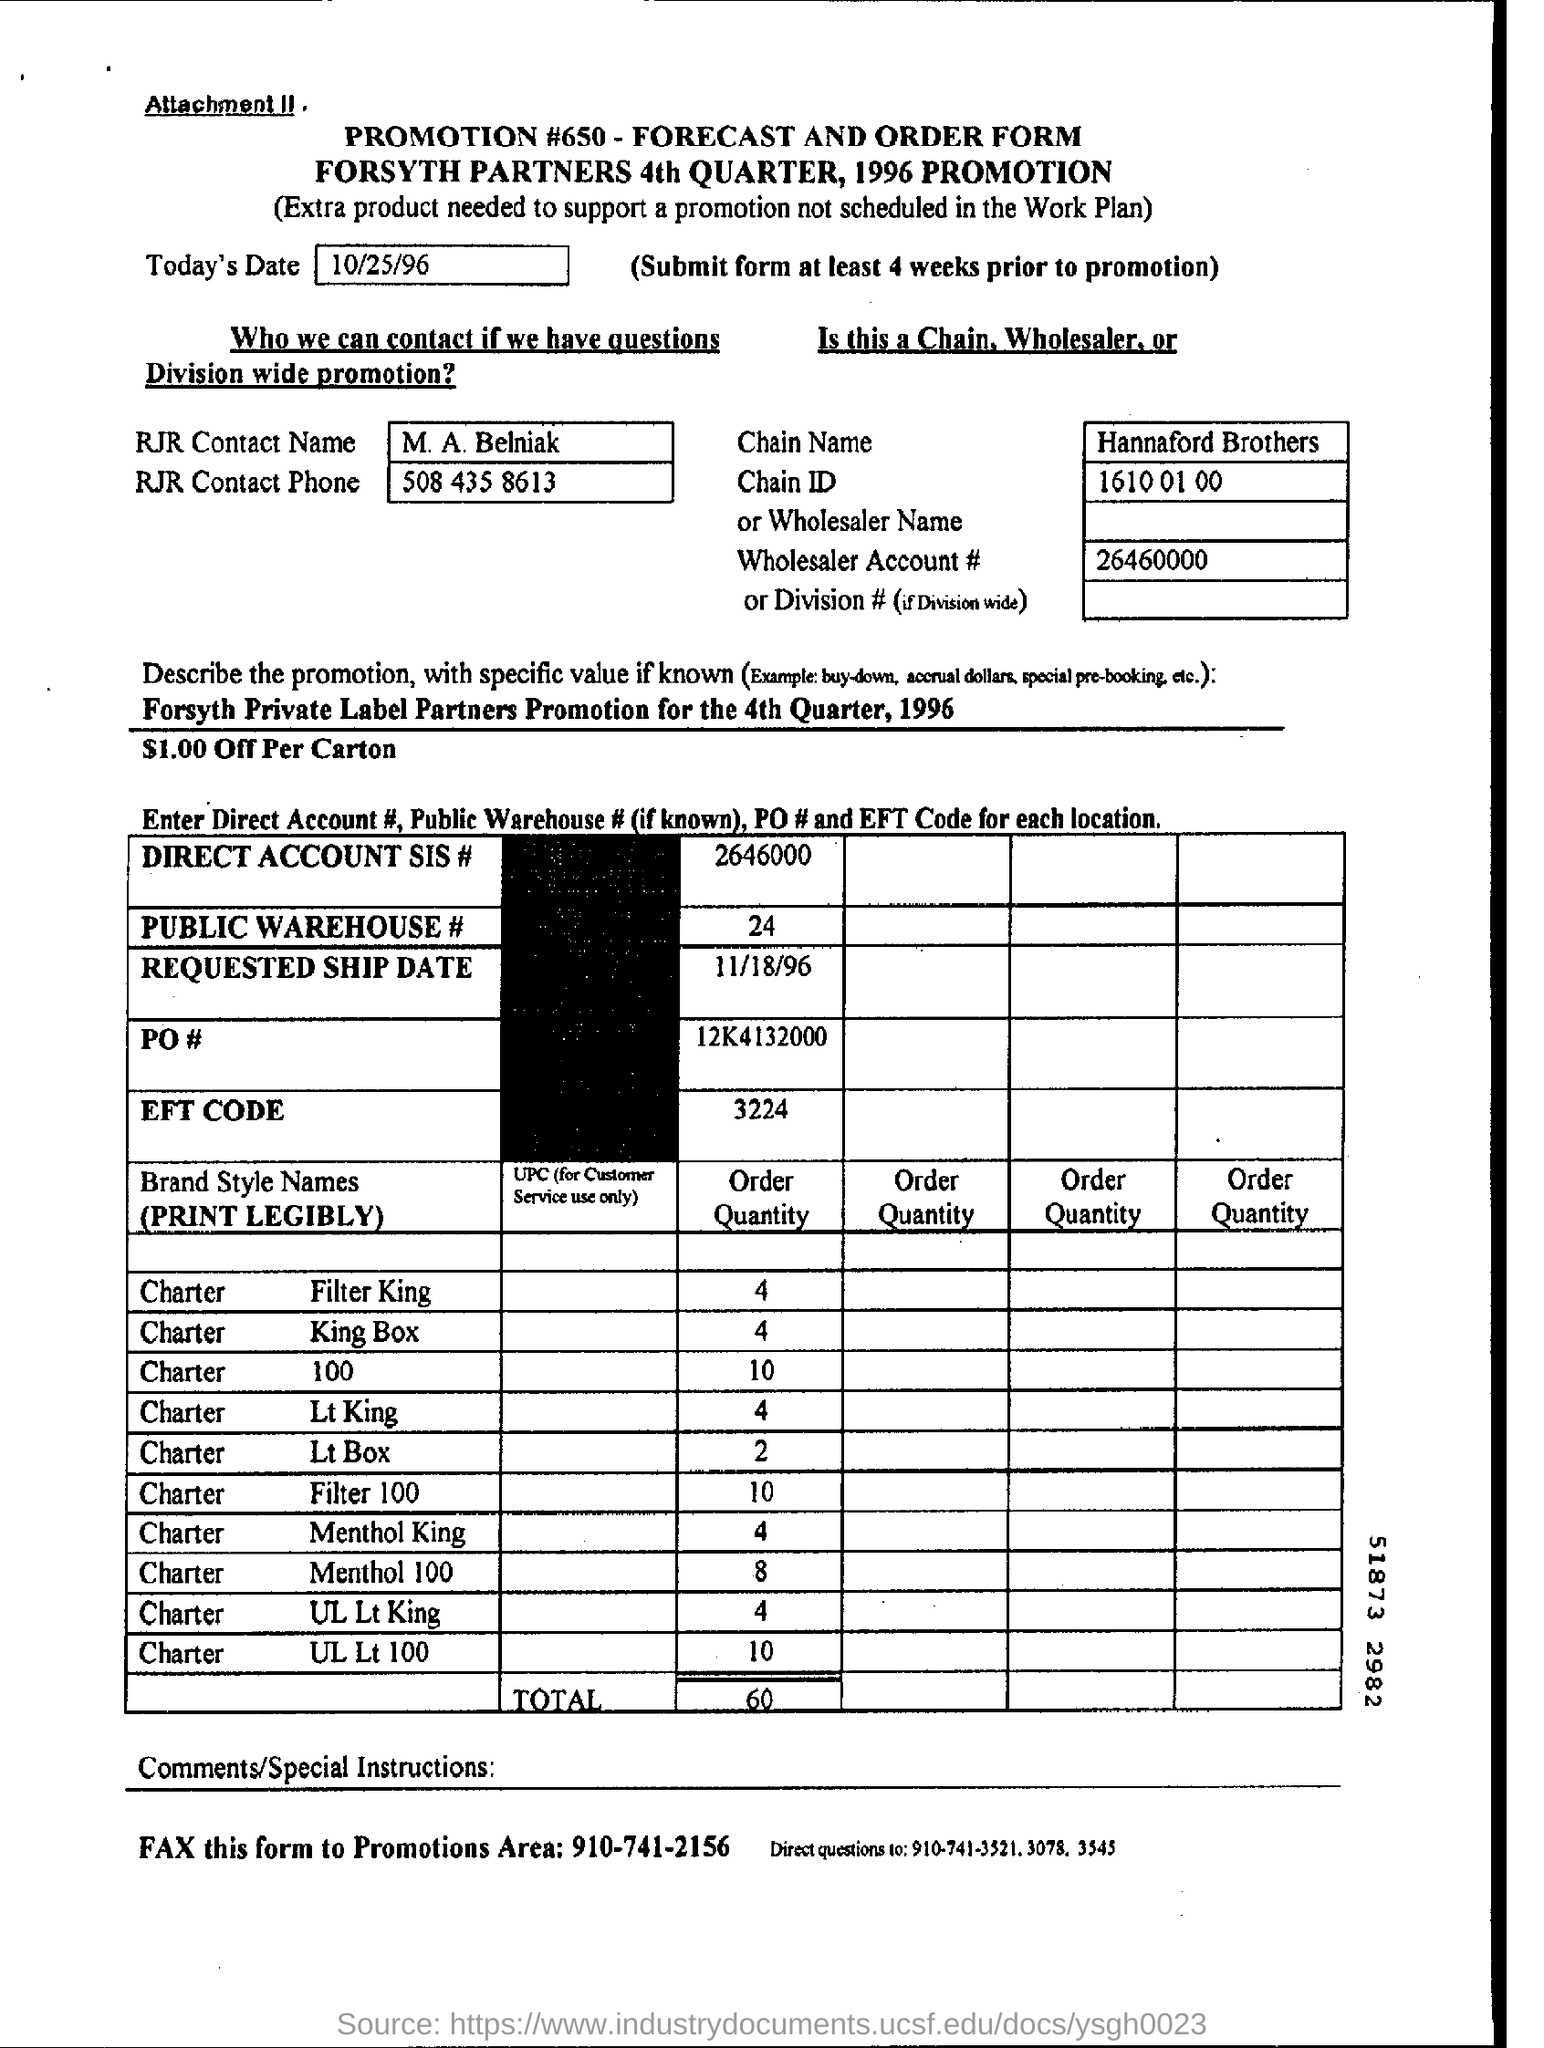When is the Forecast and order form dated?
Offer a terse response. 10/25/96. What is the promotion number mentioned on the form?
Provide a short and direct response. 650. What is the name of the RJR contact person?
Offer a terse response. M. A. Belniak. What is the total order quantity?
Your answer should be very brief. 60. What is the EFT code mentioned on the form?
Provide a short and direct response. 3224. 